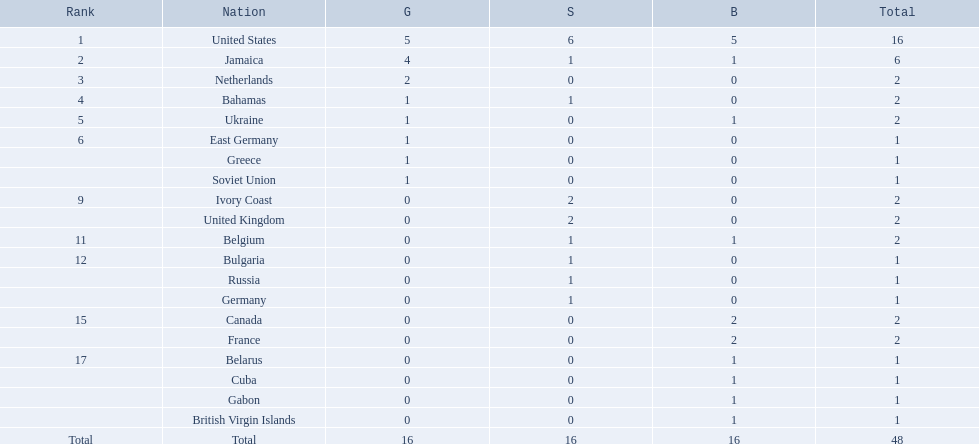What countries competed? United States, Jamaica, Netherlands, Bahamas, Ukraine, East Germany, Greece, Soviet Union, Ivory Coast, United Kingdom, Belgium, Bulgaria, Russia, Germany, Canada, France, Belarus, Cuba, Gabon, British Virgin Islands. Which countries won gold medals? United States, Jamaica, Netherlands, Bahamas, Ukraine, East Germany, Greece, Soviet Union. Which country had the second most medals? Jamaica. 